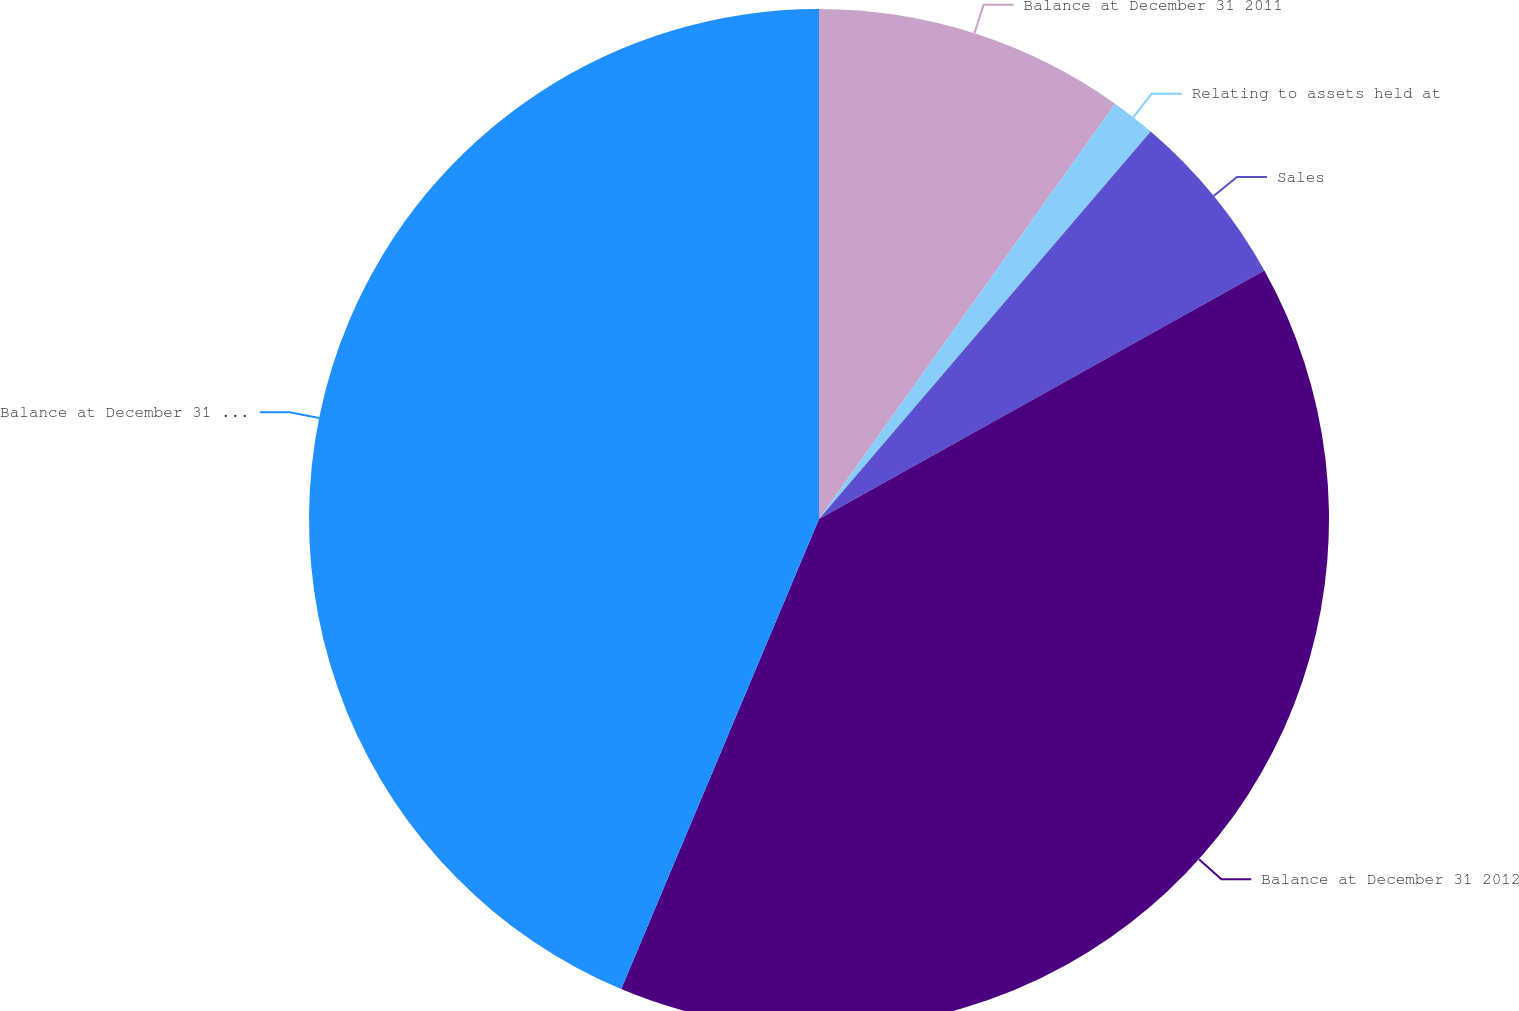Convert chart. <chart><loc_0><loc_0><loc_500><loc_500><pie_chart><fcel>Balance at December 31 2011<fcel>Relating to assets held at<fcel>Sales<fcel>Balance at December 31 2012<fcel>Balance at December 31 2013<nl><fcel>9.86%<fcel>1.41%<fcel>5.63%<fcel>39.44%<fcel>43.66%<nl></chart> 